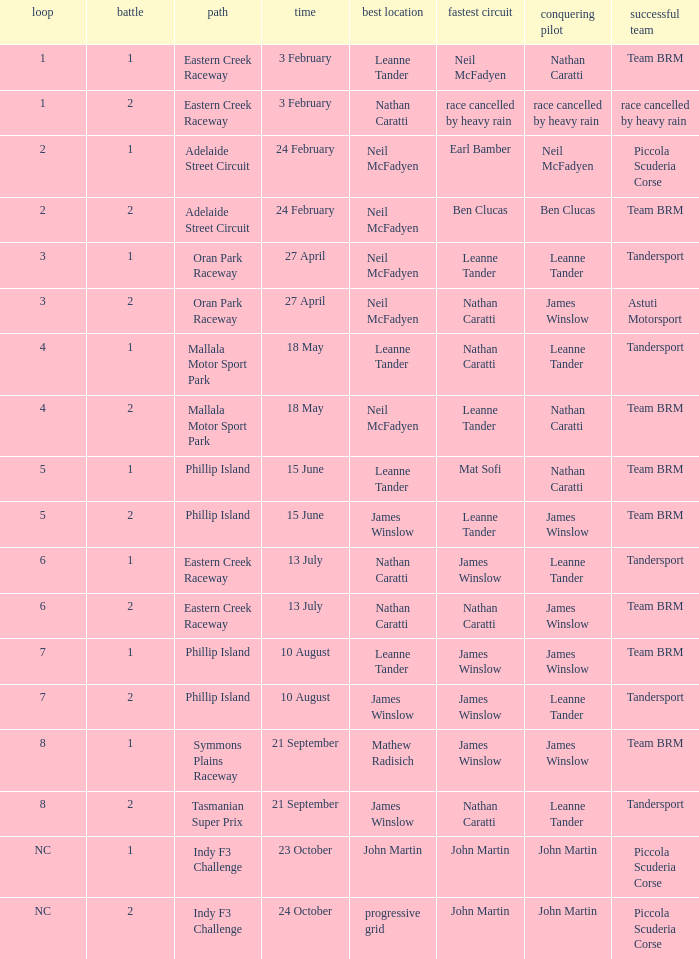What is the highest race number in the Phillip Island circuit with James Winslow as the winning driver and pole position? 2.0. 